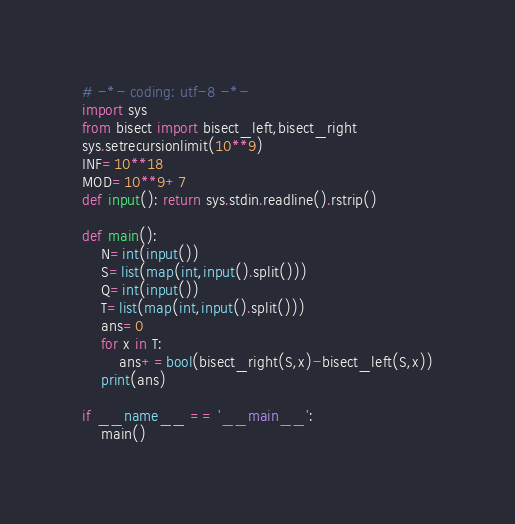Convert code to text. <code><loc_0><loc_0><loc_500><loc_500><_Python_># -*- coding: utf-8 -*-
import sys
from bisect import bisect_left,bisect_right
sys.setrecursionlimit(10**9)
INF=10**18
MOD=10**9+7
def input(): return sys.stdin.readline().rstrip()

def main():
    N=int(input())
    S=list(map(int,input().split()))
    Q=int(input())
    T=list(map(int,input().split()))
    ans=0
    for x in T:
        ans+=bool(bisect_right(S,x)-bisect_left(S,x))
    print(ans)

if __name__ == '__main__':
    main()

</code> 